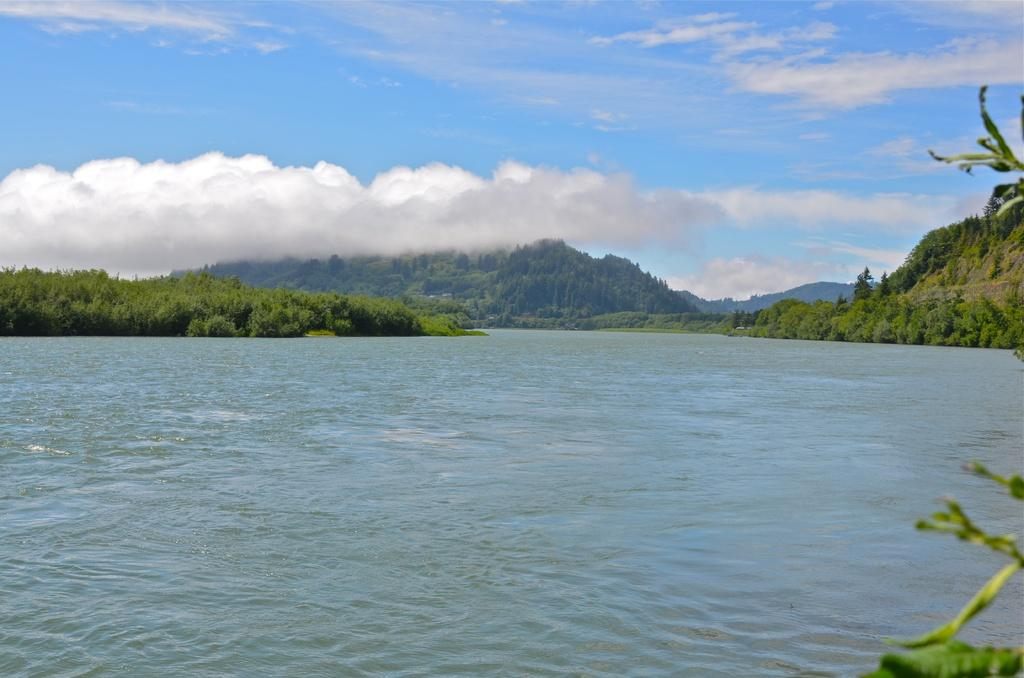What type of natural feature is present in the image? There is a river in the image. What other elements can be seen in the image? There are plants and hills visible in the image. What is visible in the sky in the image? There are clouds in the sky. What type of anger can be seen on the face of the cook in the alley in the image? There is no cook or alley present in the image, and therefore no anger can be observed. 